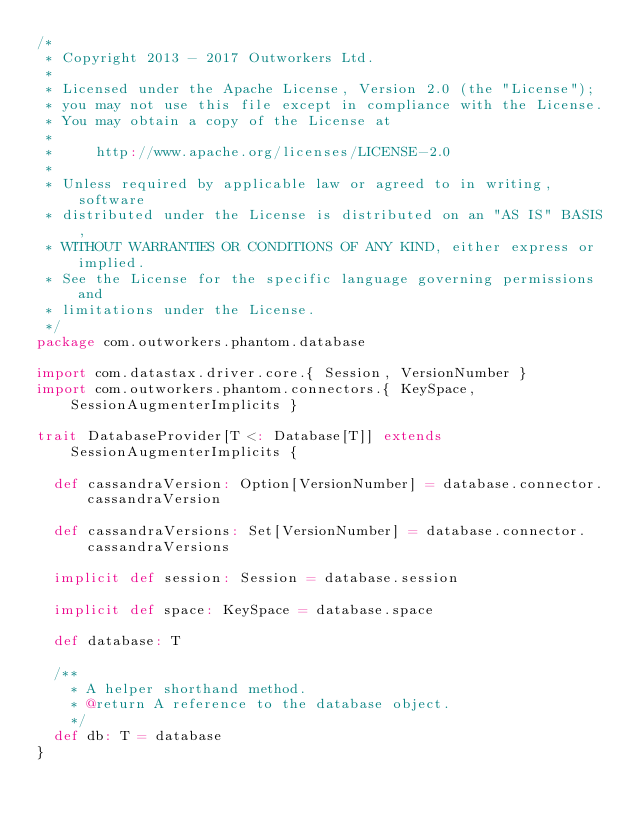<code> <loc_0><loc_0><loc_500><loc_500><_Scala_>/*
 * Copyright 2013 - 2017 Outworkers Ltd.
 *
 * Licensed under the Apache License, Version 2.0 (the "License");
 * you may not use this file except in compliance with the License.
 * You may obtain a copy of the License at
 *
 *     http://www.apache.org/licenses/LICENSE-2.0
 *
 * Unless required by applicable law or agreed to in writing, software
 * distributed under the License is distributed on an "AS IS" BASIS,
 * WITHOUT WARRANTIES OR CONDITIONS OF ANY KIND, either express or implied.
 * See the License for the specific language governing permissions and
 * limitations under the License.
 */
package com.outworkers.phantom.database

import com.datastax.driver.core.{ Session, VersionNumber }
import com.outworkers.phantom.connectors.{ KeySpace, SessionAugmenterImplicits }

trait DatabaseProvider[T <: Database[T]] extends SessionAugmenterImplicits {

  def cassandraVersion: Option[VersionNumber] = database.connector.cassandraVersion

  def cassandraVersions: Set[VersionNumber] = database.connector.cassandraVersions

  implicit def session: Session = database.session

  implicit def space: KeySpace = database.space

  def database: T

  /**
    * A helper shorthand method.
    * @return A reference to the database object.
    */
  def db: T = database
}
</code> 